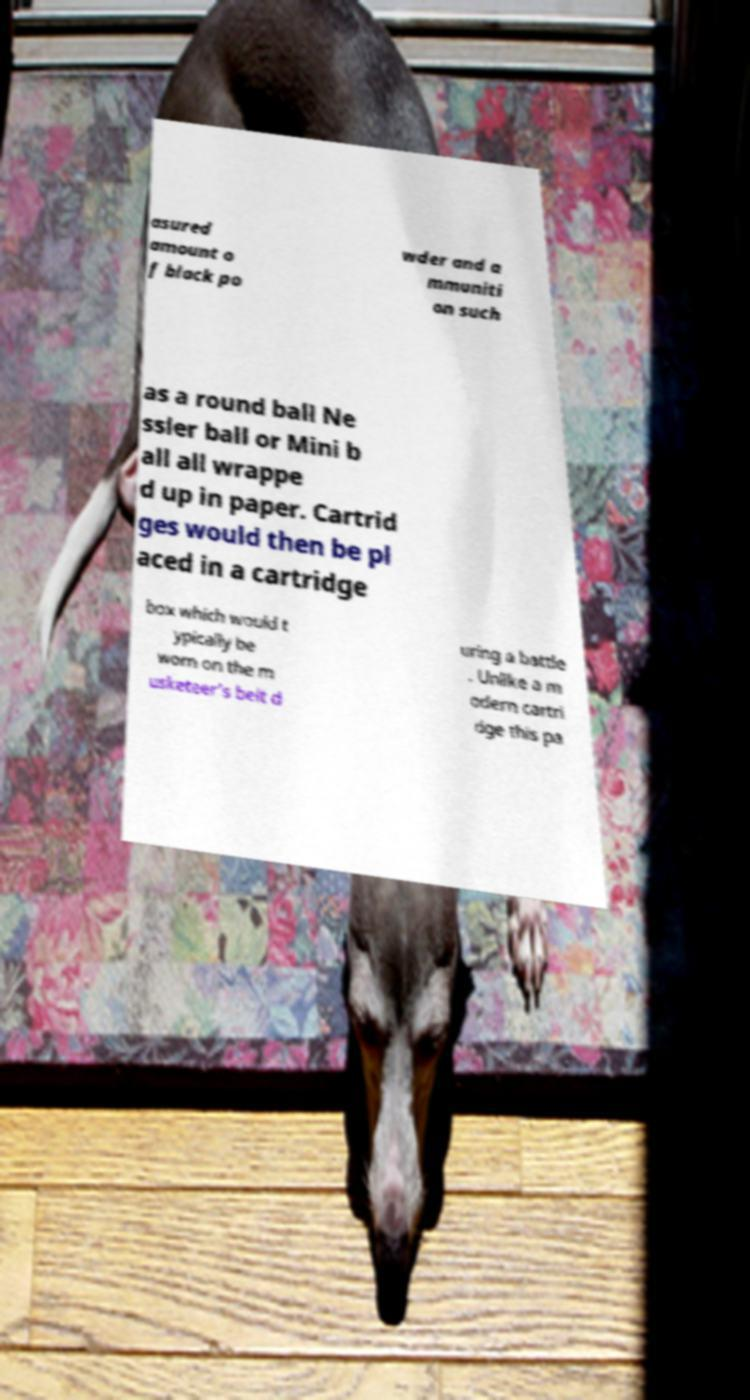There's text embedded in this image that I need extracted. Can you transcribe it verbatim? asured amount o f black po wder and a mmuniti on such as a round ball Ne ssler ball or Mini b all all wrappe d up in paper. Cartrid ges would then be pl aced in a cartridge box which would t ypically be worn on the m usketeer's belt d uring a battle . Unlike a m odern cartri dge this pa 